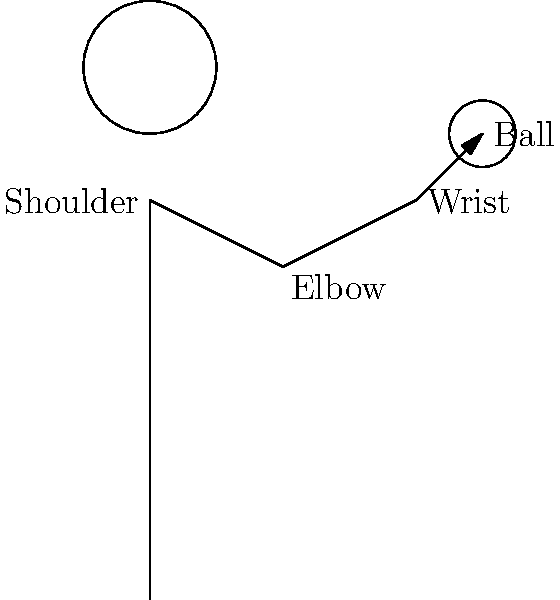In the stick figure diagram of a child throwing a ball, which joint plays a crucial role in generating the most power for the throw, and why is this important for the ball's trajectory? To understand the biomechanics of a child throwing a ball, let's break down the movement:

1. The throwing motion typically involves a kinetic chain, starting from the legs and moving up through the body.

2. In the arm specifically, there are three main joints involved: the shoulder, elbow, and wrist.

3. The shoulder joint allows for a wide range of motion, including rotation and abduction of the arm.

4. The elbow joint acts as a pivot point, allowing for extension and flexion of the forearm.

5. The wrist joint provides the final adjustments for accuracy and spin on the ball.

6. Among these, the shoulder joint generates the most power for the throw because:
   a) It has the largest range of motion.
   b) It connects the arm to the larger muscle groups in the torso.
   c) It allows for rotational movement, which is crucial for generating velocity.

7. The power generated at the shoulder is important for the ball's trajectory because:
   a) It determines the initial velocity of the ball.
   b) Higher initial velocity results in a longer distance thrown.
   c) It allows for greater control over the arc of the throw.

8. Understanding this concept is crucial for children's development, as it helps them learn proper throwing techniques and improve their physical skills.

For a children's book author, this knowledge can be used to create stories that accurately depict movement and encourage children to understand and improve their motor skills.
Answer: The shoulder joint, as it generates the most power and significantly influences the ball's trajectory. 